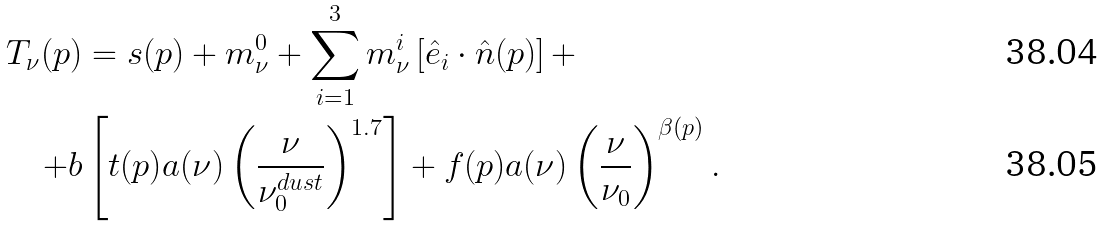Convert formula to latex. <formula><loc_0><loc_0><loc_500><loc_500>T _ { \nu } ( p ) & = s ( p ) + m ^ { 0 } _ { \nu } + \sum _ { i = 1 } ^ { 3 } m ^ { i } _ { \nu } \left [ \hat { e } _ { i } \cdot \hat { n } ( p ) \right ] + \\ + b & \left [ t ( p ) a ( \nu ) \left ( \frac { \nu } { \nu _ { 0 } ^ { d u s t } } \right ) ^ { 1 . 7 } \right ] + f ( p ) a ( \nu ) \left ( \frac { \nu } { \nu _ { 0 } } \right ) ^ { \beta ( p ) } .</formula> 